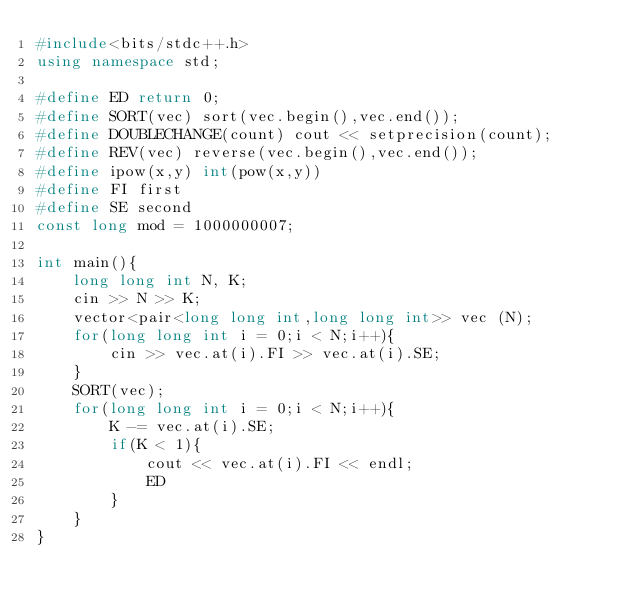<code> <loc_0><loc_0><loc_500><loc_500><_C++_>#include<bits/stdc++.h>
using namespace std;

#define ED return 0;
#define SORT(vec) sort(vec.begin(),vec.end());
#define DOUBLECHANGE(count) cout << setprecision(count);
#define REV(vec) reverse(vec.begin(),vec.end());
#define ipow(x,y) int(pow(x,y))
#define FI first
#define SE second
const long mod = 1000000007;

int main(){
    long long int N, K;
    cin >> N >> K;
    vector<pair<long long int,long long int>> vec (N);
    for(long long int i = 0;i < N;i++){
        cin >> vec.at(i).FI >> vec.at(i).SE;
    }
    SORT(vec);
    for(long long int i = 0;i < N;i++){
        K -= vec.at(i).SE;
        if(K < 1){
            cout << vec.at(i).FI << endl;
            ED
        }
    }
}
</code> 